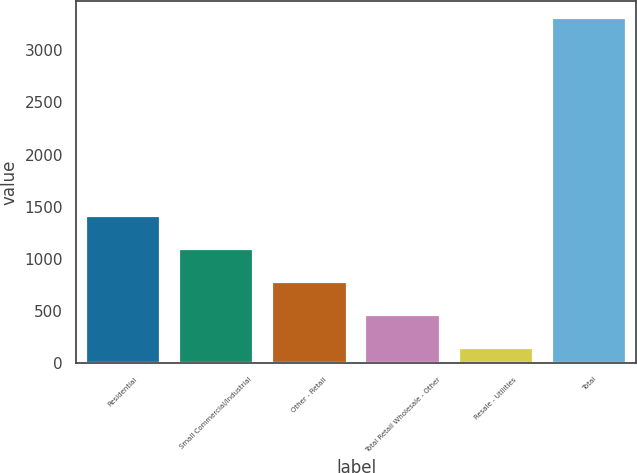<chart> <loc_0><loc_0><loc_500><loc_500><bar_chart><fcel>Residential<fcel>Small Commercial/Industrial<fcel>Other - Retail<fcel>Total Retail Wholesale - Other<fcel>Resale - Utilities<fcel>Total<nl><fcel>1408.8<fcel>1092.4<fcel>776<fcel>459.6<fcel>143.2<fcel>3307.2<nl></chart> 